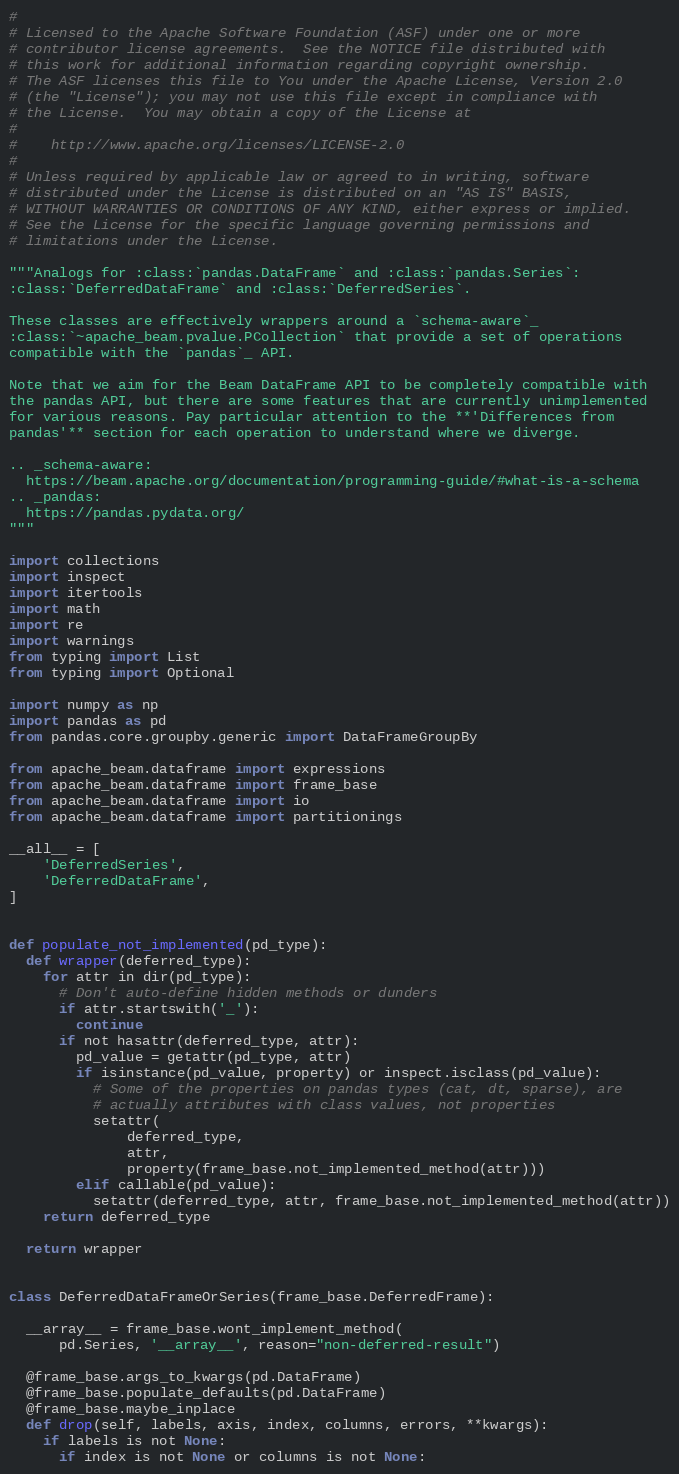Convert code to text. <code><loc_0><loc_0><loc_500><loc_500><_Python_>#
# Licensed to the Apache Software Foundation (ASF) under one or more
# contributor license agreements.  See the NOTICE file distributed with
# this work for additional information regarding copyright ownership.
# The ASF licenses this file to You under the Apache License, Version 2.0
# (the "License"); you may not use this file except in compliance with
# the License.  You may obtain a copy of the License at
#
#    http://www.apache.org/licenses/LICENSE-2.0
#
# Unless required by applicable law or agreed to in writing, software
# distributed under the License is distributed on an "AS IS" BASIS,
# WITHOUT WARRANTIES OR CONDITIONS OF ANY KIND, either express or implied.
# See the License for the specific language governing permissions and
# limitations under the License.

"""Analogs for :class:`pandas.DataFrame` and :class:`pandas.Series`:
:class:`DeferredDataFrame` and :class:`DeferredSeries`.

These classes are effectively wrappers around a `schema-aware`_
:class:`~apache_beam.pvalue.PCollection` that provide a set of operations
compatible with the `pandas`_ API.

Note that we aim for the Beam DataFrame API to be completely compatible with
the pandas API, but there are some features that are currently unimplemented
for various reasons. Pay particular attention to the **'Differences from
pandas'** section for each operation to understand where we diverge.

.. _schema-aware:
  https://beam.apache.org/documentation/programming-guide/#what-is-a-schema
.. _pandas:
  https://pandas.pydata.org/
"""

import collections
import inspect
import itertools
import math
import re
import warnings
from typing import List
from typing import Optional

import numpy as np
import pandas as pd
from pandas.core.groupby.generic import DataFrameGroupBy

from apache_beam.dataframe import expressions
from apache_beam.dataframe import frame_base
from apache_beam.dataframe import io
from apache_beam.dataframe import partitionings

__all__ = [
    'DeferredSeries',
    'DeferredDataFrame',
]


def populate_not_implemented(pd_type):
  def wrapper(deferred_type):
    for attr in dir(pd_type):
      # Don't auto-define hidden methods or dunders
      if attr.startswith('_'):
        continue
      if not hasattr(deferred_type, attr):
        pd_value = getattr(pd_type, attr)
        if isinstance(pd_value, property) or inspect.isclass(pd_value):
          # Some of the properties on pandas types (cat, dt, sparse), are
          # actually attributes with class values, not properties
          setattr(
              deferred_type,
              attr,
              property(frame_base.not_implemented_method(attr)))
        elif callable(pd_value):
          setattr(deferred_type, attr, frame_base.not_implemented_method(attr))
    return deferred_type

  return wrapper


class DeferredDataFrameOrSeries(frame_base.DeferredFrame):

  __array__ = frame_base.wont_implement_method(
      pd.Series, '__array__', reason="non-deferred-result")

  @frame_base.args_to_kwargs(pd.DataFrame)
  @frame_base.populate_defaults(pd.DataFrame)
  @frame_base.maybe_inplace
  def drop(self, labels, axis, index, columns, errors, **kwargs):
    if labels is not None:
      if index is not None or columns is not None:</code> 